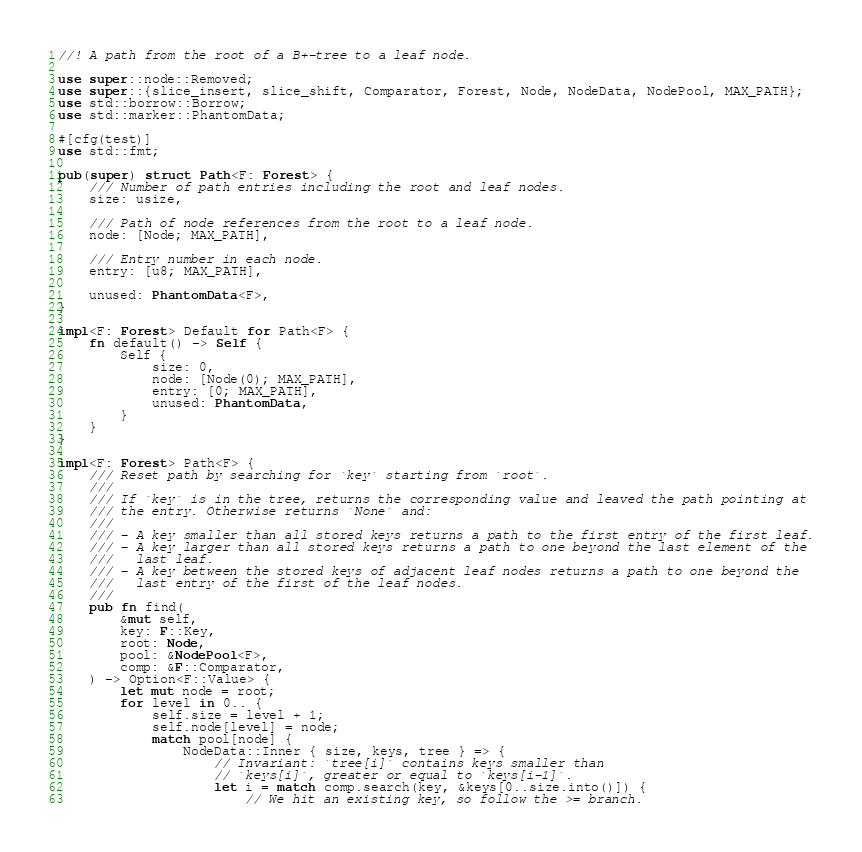<code> <loc_0><loc_0><loc_500><loc_500><_Rust_>//! A path from the root of a B+-tree to a leaf node.

use super::node::Removed;
use super::{slice_insert, slice_shift, Comparator, Forest, Node, NodeData, NodePool, MAX_PATH};
use std::borrow::Borrow;
use std::marker::PhantomData;

#[cfg(test)]
use std::fmt;

pub(super) struct Path<F: Forest> {
    /// Number of path entries including the root and leaf nodes.
    size: usize,

    /// Path of node references from the root to a leaf node.
    node: [Node; MAX_PATH],

    /// Entry number in each node.
    entry: [u8; MAX_PATH],

    unused: PhantomData<F>,
}

impl<F: Forest> Default for Path<F> {
    fn default() -> Self {
        Self {
            size: 0,
            node: [Node(0); MAX_PATH],
            entry: [0; MAX_PATH],
            unused: PhantomData,
        }
    }
}

impl<F: Forest> Path<F> {
    /// Reset path by searching for `key` starting from `root`.
    ///
    /// If `key` is in the tree, returns the corresponding value and leaved the path pointing at
    /// the entry. Otherwise returns `None` and:
    ///
    /// - A key smaller than all stored keys returns a path to the first entry of the first leaf.
    /// - A key larger than all stored keys returns a path to one beyond the last element of the
    ///   last leaf.
    /// - A key between the stored keys of adjacent leaf nodes returns a path to one beyond the
    ///   last entry of the first of the leaf nodes.
    ///
    pub fn find(
        &mut self,
        key: F::Key,
        root: Node,
        pool: &NodePool<F>,
        comp: &F::Comparator,
    ) -> Option<F::Value> {
        let mut node = root;
        for level in 0.. {
            self.size = level + 1;
            self.node[level] = node;
            match pool[node] {
                NodeData::Inner { size, keys, tree } => {
                    // Invariant: `tree[i]` contains keys smaller than
                    // `keys[i]`, greater or equal to `keys[i-1]`.
                    let i = match comp.search(key, &keys[0..size.into()]) {
                        // We hit an existing key, so follow the >= branch.</code> 